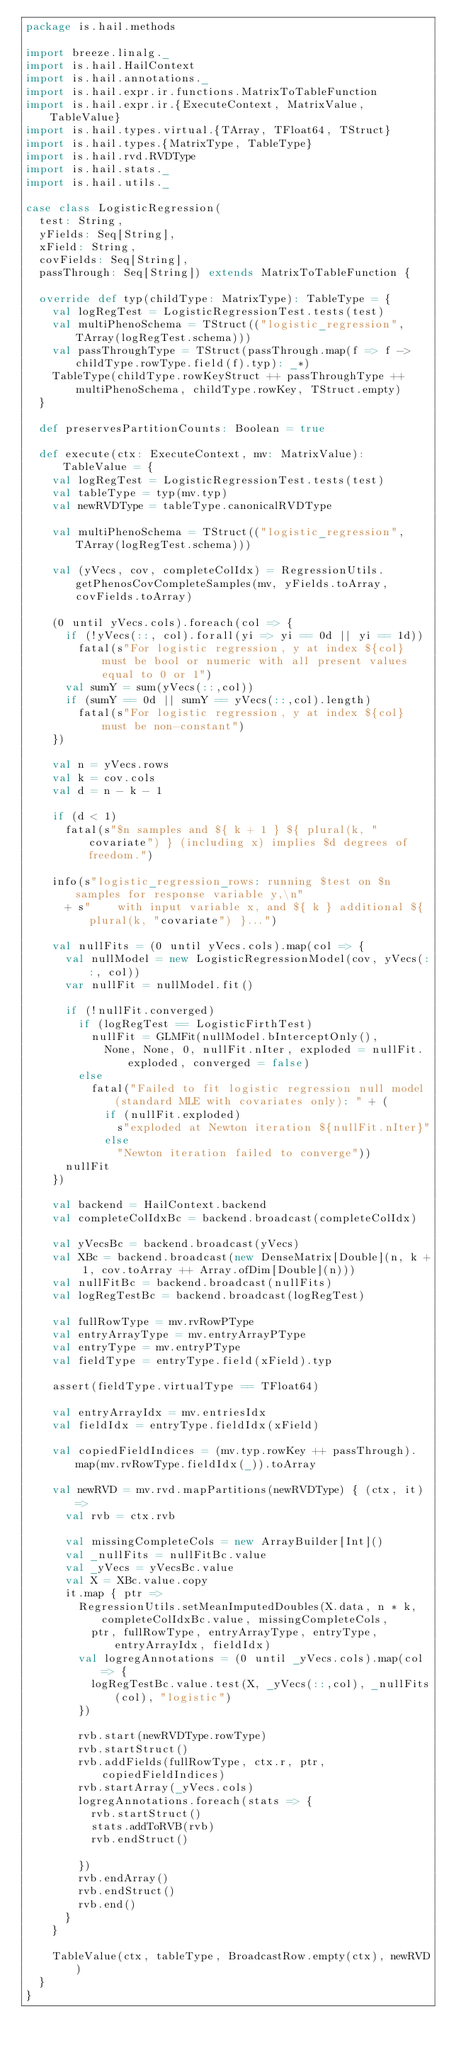Convert code to text. <code><loc_0><loc_0><loc_500><loc_500><_Scala_>package is.hail.methods

import breeze.linalg._
import is.hail.HailContext
import is.hail.annotations._
import is.hail.expr.ir.functions.MatrixToTableFunction
import is.hail.expr.ir.{ExecuteContext, MatrixValue, TableValue}
import is.hail.types.virtual.{TArray, TFloat64, TStruct}
import is.hail.types.{MatrixType, TableType}
import is.hail.rvd.RVDType
import is.hail.stats._
import is.hail.utils._

case class LogisticRegression(
  test: String,
  yFields: Seq[String],
  xField: String,
  covFields: Seq[String],
  passThrough: Seq[String]) extends MatrixToTableFunction {

  override def typ(childType: MatrixType): TableType = {
    val logRegTest = LogisticRegressionTest.tests(test)
    val multiPhenoSchema = TStruct(("logistic_regression", TArray(logRegTest.schema)))
    val passThroughType = TStruct(passThrough.map(f => f -> childType.rowType.field(f).typ): _*)
    TableType(childType.rowKeyStruct ++ passThroughType ++ multiPhenoSchema, childType.rowKey, TStruct.empty)
  }

  def preservesPartitionCounts: Boolean = true

  def execute(ctx: ExecuteContext, mv: MatrixValue): TableValue = {
    val logRegTest = LogisticRegressionTest.tests(test)
    val tableType = typ(mv.typ)
    val newRVDType = tableType.canonicalRVDType

    val multiPhenoSchema = TStruct(("logistic_regression", TArray(logRegTest.schema)))

    val (yVecs, cov, completeColIdx) = RegressionUtils.getPhenosCovCompleteSamples(mv, yFields.toArray, covFields.toArray)

    (0 until yVecs.cols).foreach(col => {
      if (!yVecs(::, col).forall(yi => yi == 0d || yi == 1d))
        fatal(s"For logistic regression, y at index ${col} must be bool or numeric with all present values equal to 0 or 1")
      val sumY = sum(yVecs(::,col))
      if (sumY == 0d || sumY == yVecs(::,col).length)
        fatal(s"For logistic regression, y at index ${col} must be non-constant")
    })

    val n = yVecs.rows
    val k = cov.cols
    val d = n - k - 1

    if (d < 1)
      fatal(s"$n samples and ${ k + 1 } ${ plural(k, "covariate") } (including x) implies $d degrees of freedom.")

    info(s"logistic_regression_rows: running $test on $n samples for response variable y,\n"
      + s"    with input variable x, and ${ k } additional ${ plural(k, "covariate") }...")

    val nullFits = (0 until yVecs.cols).map(col => {
      val nullModel = new LogisticRegressionModel(cov, yVecs(::, col))
      var nullFit = nullModel.fit()

      if (!nullFit.converged)
        if (logRegTest == LogisticFirthTest)
          nullFit = GLMFit(nullModel.bInterceptOnly(),
            None, None, 0, nullFit.nIter, exploded = nullFit.exploded, converged = false)
        else
          fatal("Failed to fit logistic regression null model (standard MLE with covariates only): " + (
            if (nullFit.exploded)
              s"exploded at Newton iteration ${nullFit.nIter}"
            else
              "Newton iteration failed to converge"))
      nullFit
    })

    val backend = HailContext.backend
    val completeColIdxBc = backend.broadcast(completeColIdx)

    val yVecsBc = backend.broadcast(yVecs)
    val XBc = backend.broadcast(new DenseMatrix[Double](n, k + 1, cov.toArray ++ Array.ofDim[Double](n)))
    val nullFitBc = backend.broadcast(nullFits)
    val logRegTestBc = backend.broadcast(logRegTest)

    val fullRowType = mv.rvRowPType
    val entryArrayType = mv.entryArrayPType
    val entryType = mv.entryPType
    val fieldType = entryType.field(xField).typ

    assert(fieldType.virtualType == TFloat64)

    val entryArrayIdx = mv.entriesIdx
    val fieldIdx = entryType.fieldIdx(xField)

    val copiedFieldIndices = (mv.typ.rowKey ++ passThrough).map(mv.rvRowType.fieldIdx(_)).toArray

    val newRVD = mv.rvd.mapPartitions(newRVDType) { (ctx, it) =>
      val rvb = ctx.rvb

      val missingCompleteCols = new ArrayBuilder[Int]()
      val _nullFits = nullFitBc.value
      val _yVecs = yVecsBc.value
      val X = XBc.value.copy
      it.map { ptr =>
        RegressionUtils.setMeanImputedDoubles(X.data, n * k, completeColIdxBc.value, missingCompleteCols,
          ptr, fullRowType, entryArrayType, entryType, entryArrayIdx, fieldIdx)
        val logregAnnotations = (0 until _yVecs.cols).map(col => {
          logRegTestBc.value.test(X, _yVecs(::,col), _nullFits(col), "logistic")
        })

        rvb.start(newRVDType.rowType)
        rvb.startStruct()
        rvb.addFields(fullRowType, ctx.r, ptr, copiedFieldIndices)
        rvb.startArray(_yVecs.cols)
        logregAnnotations.foreach(stats => {
          rvb.startStruct()
          stats.addToRVB(rvb)
          rvb.endStruct()

        })
        rvb.endArray()
        rvb.endStruct()
        rvb.end()
      }
    }

    TableValue(ctx, tableType, BroadcastRow.empty(ctx), newRVD)
  }
}
</code> 